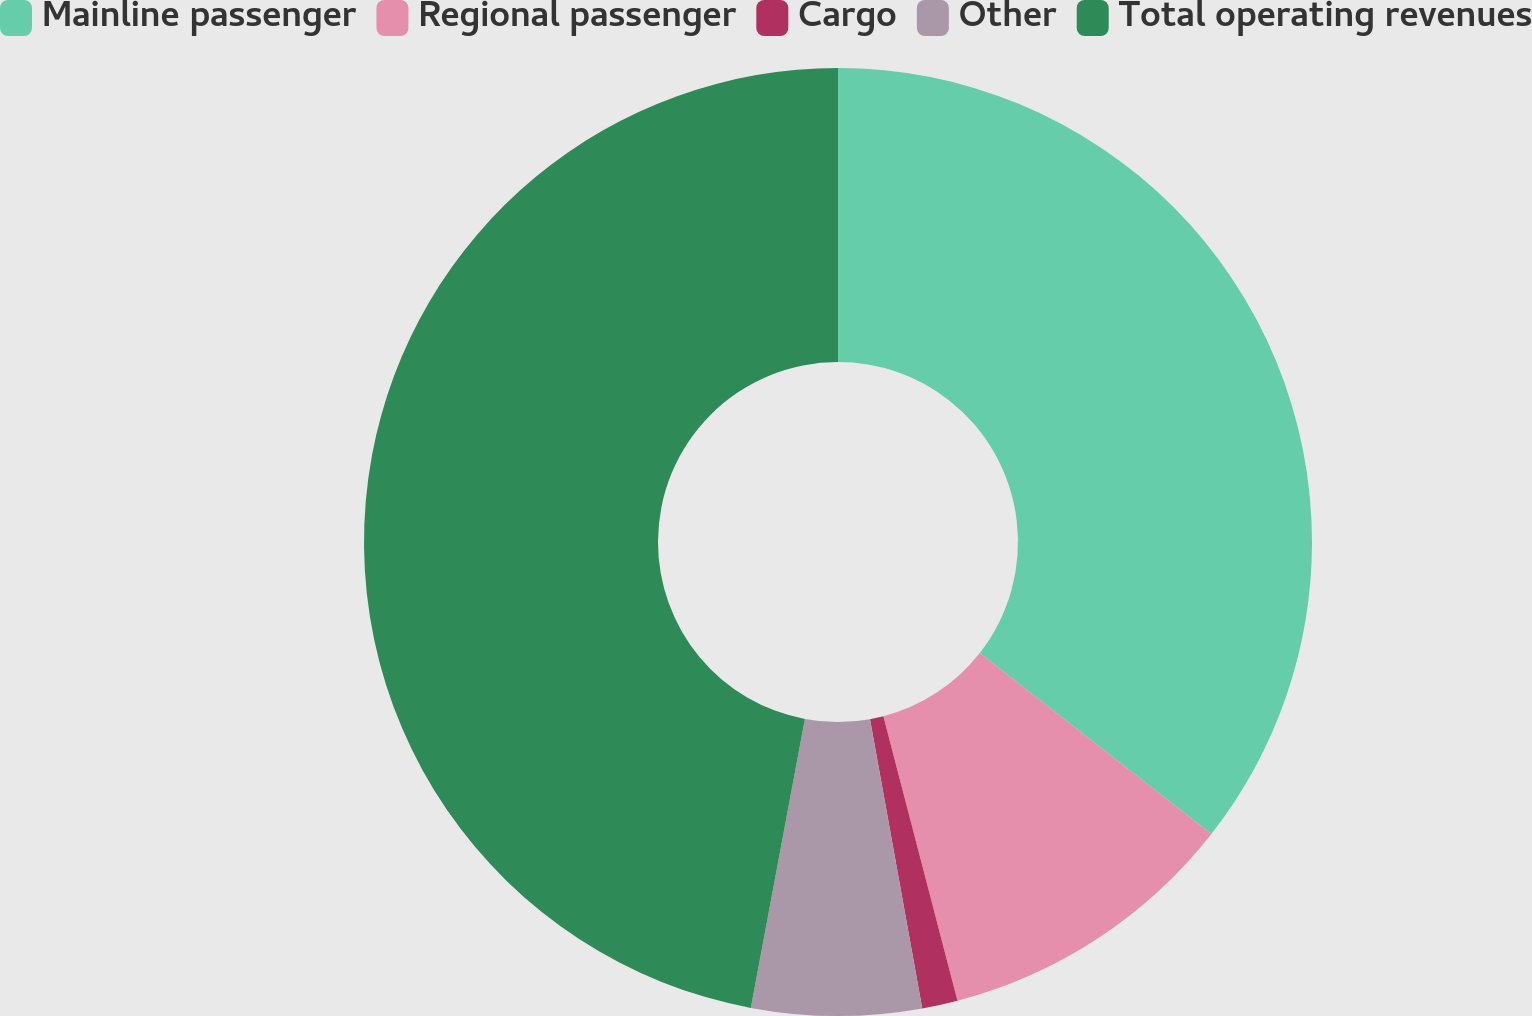Convert chart. <chart><loc_0><loc_0><loc_500><loc_500><pie_chart><fcel>Mainline passenger<fcel>Regional passenger<fcel>Cargo<fcel>Other<fcel>Total operating revenues<nl><fcel>35.57%<fcel>10.38%<fcel>1.21%<fcel>5.79%<fcel>47.06%<nl></chart> 